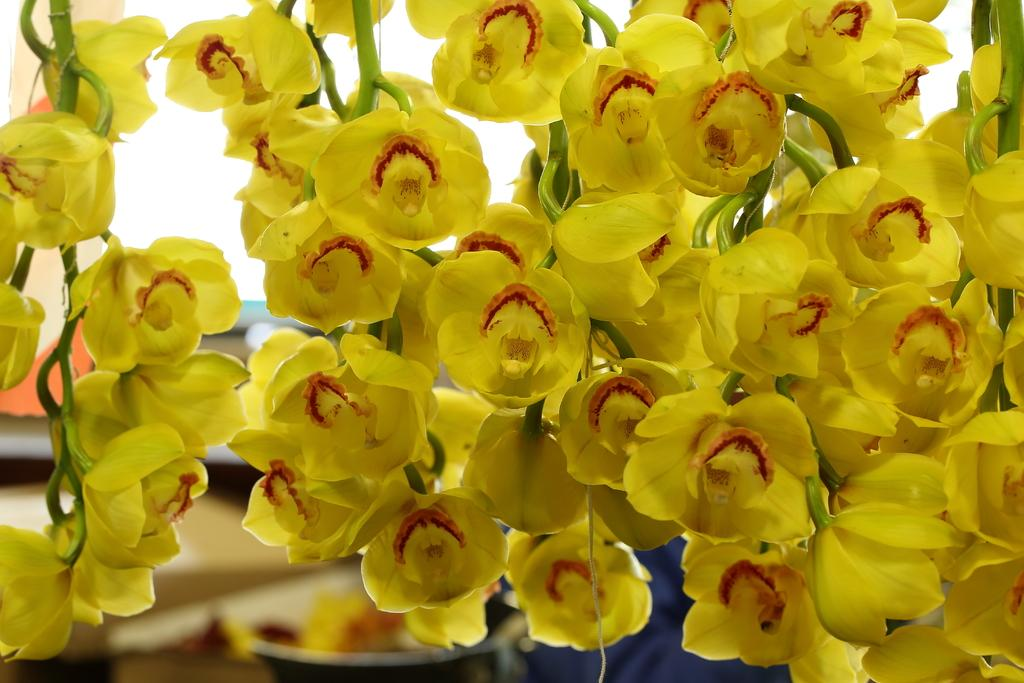What is the main subject of the image? The main subject of the image is flowers. Where are the flowers located in the image? The flowers are in the center of the image. What colors can be seen on the flowers? The flowers have yellow and red colors. What type of bike can be seen parked near the flowers in the image? There is no bike present in the image; it only features flowers with yellow and red colors. 